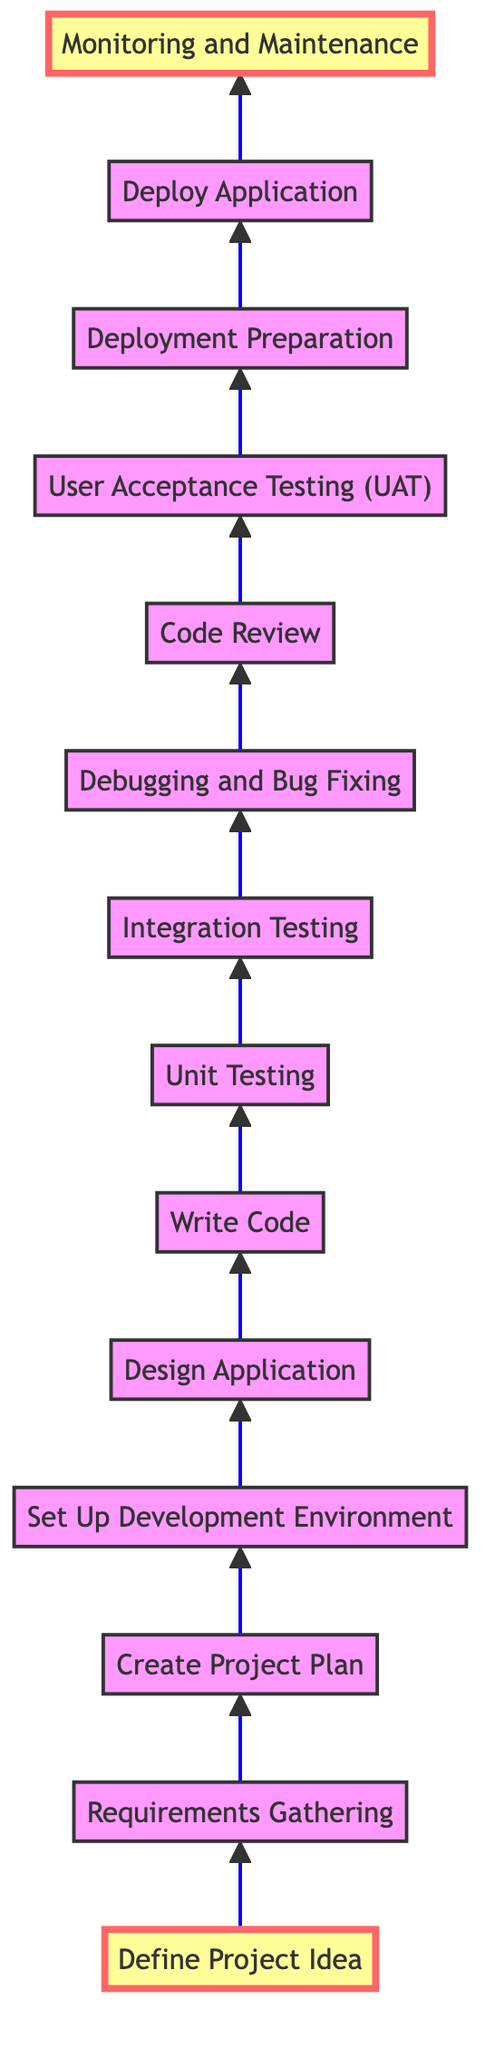What is the first step in the Java project workflow? The diagram clearly shows that the first step is to "Define Project Idea," which is the starting point of the workflow.
Answer: Define Project Idea What comes after "User Acceptance Testing (UAT)"? According to the flow chart, the next step after "User Acceptance Testing (UAT)" is "Deployment Preparation." This indicates the sequence of the workflow.
Answer: Deployment Preparation How many nodes are present in the diagram? By counting all the unique steps from "Define Project Idea" to "Monitoring and Maintenance," there are a total of 14 nodes in the diagram.
Answer: 14 Which step directly precedes "Write Code"? The diagram shows that "Design Application" is the step that comes directly before "Write Code." This indicates the order of tasks in the Java project workflow.
Answer: Design Application What is the last step in the workflow? The last step indicated in the flow chart is "Monitoring and Maintenance," signifying ongoing support after the application is deployed.
Answer: Monitoring and Maintenance What type of testing follows "Unit Testing"? The flowchart indicates that "Integration Testing" follows "Unit Testing," showing the progression of testing in the development process.
Answer: Integration Testing Which steps are highlighted in the diagram? The diagram highlights "Define Project Idea" at the beginning and "Monitoring and Maintenance" at the end, indicating the starting and concluding phases of the workflow.
Answer: Define Project Idea, Monitoring and Maintenance How many testing stages are included in the workflow? The diagram includes two distinct stages of testing: "Unit Testing" and "Integration Testing," thus making a total of two testing stages.
Answer: 2 Which step involves collecting requirements? The step involving the collection of requirements is "Requirements Gathering," as shown in the flow chart between "Define Project Idea" and "Create Project Plan."
Answer: Requirements Gathering 